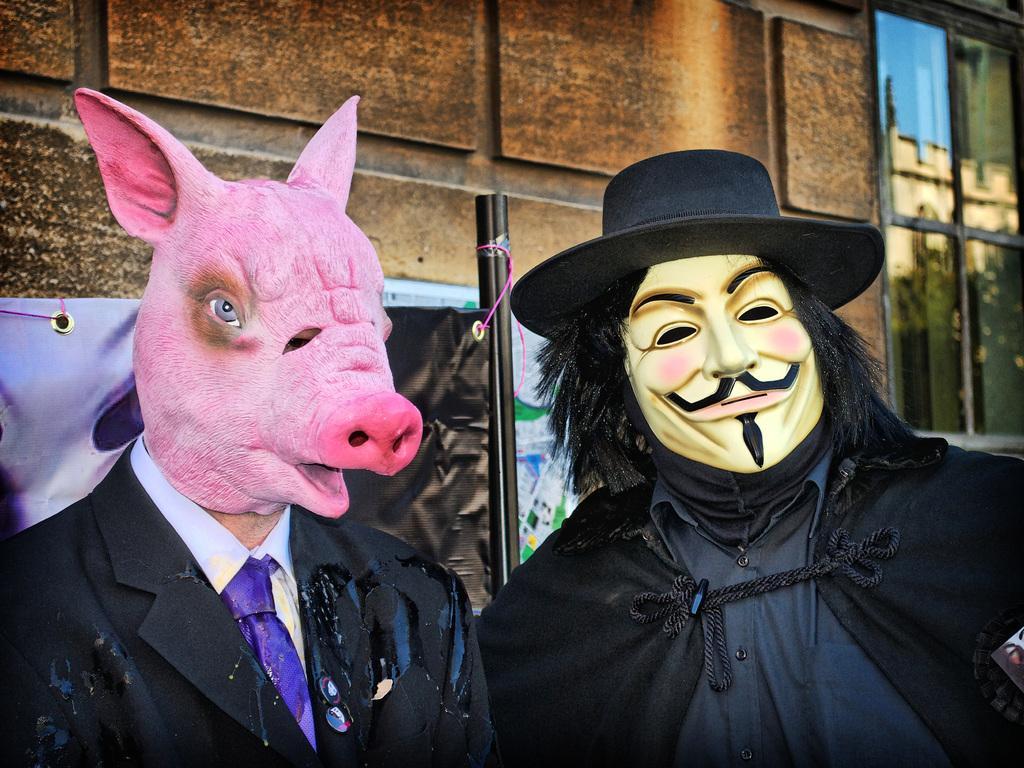Could you give a brief overview of what you see in this image? In this image I can see two persons with the masks. In the background I can see the banner, building and the glass window. 